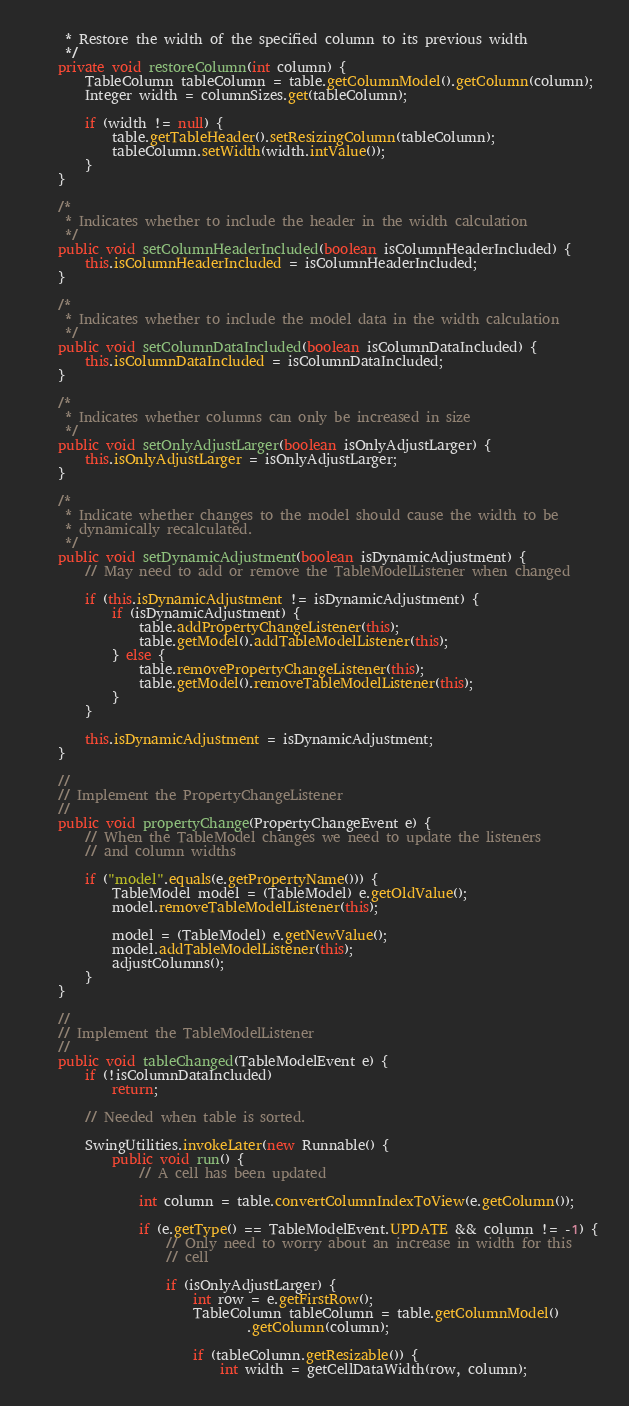Convert code to text. <code><loc_0><loc_0><loc_500><loc_500><_Java_>     * Restore the width of the specified column to its previous width
     */
    private void restoreColumn(int column) {
        TableColumn tableColumn = table.getColumnModel().getColumn(column);
        Integer width = columnSizes.get(tableColumn);

        if (width != null) {
            table.getTableHeader().setResizingColumn(tableColumn);
            tableColumn.setWidth(width.intValue());
        }
    }

    /*
     * Indicates whether to include the header in the width calculation
     */
    public void setColumnHeaderIncluded(boolean isColumnHeaderIncluded) {
        this.isColumnHeaderIncluded = isColumnHeaderIncluded;
    }

    /*
     * Indicates whether to include the model data in the width calculation
     */
    public void setColumnDataIncluded(boolean isColumnDataIncluded) {
        this.isColumnDataIncluded = isColumnDataIncluded;
    }

    /*
     * Indicates whether columns can only be increased in size
     */
    public void setOnlyAdjustLarger(boolean isOnlyAdjustLarger) {
        this.isOnlyAdjustLarger = isOnlyAdjustLarger;
    }

    /*
     * Indicate whether changes to the model should cause the width to be
     * dynamically recalculated.
     */
    public void setDynamicAdjustment(boolean isDynamicAdjustment) {
        // May need to add or remove the TableModelListener when changed

        if (this.isDynamicAdjustment != isDynamicAdjustment) {
            if (isDynamicAdjustment) {
                table.addPropertyChangeListener(this);
                table.getModel().addTableModelListener(this);
            } else {
                table.removePropertyChangeListener(this);
                table.getModel().removeTableModelListener(this);
            }
        }

        this.isDynamicAdjustment = isDynamicAdjustment;
    }

    //
    // Implement the PropertyChangeListener
    //
    public void propertyChange(PropertyChangeEvent e) {
        // When the TableModel changes we need to update the listeners
        // and column widths

        if ("model".equals(e.getPropertyName())) {
            TableModel model = (TableModel) e.getOldValue();
            model.removeTableModelListener(this);

            model = (TableModel) e.getNewValue();
            model.addTableModelListener(this);
            adjustColumns();
        }
    }

    //
    // Implement the TableModelListener
    //
    public void tableChanged(TableModelEvent e) {
        if (!isColumnDataIncluded)
            return;

        // Needed when table is sorted.

        SwingUtilities.invokeLater(new Runnable() {
            public void run() {
                // A cell has been updated

                int column = table.convertColumnIndexToView(e.getColumn());

                if (e.getType() == TableModelEvent.UPDATE && column != -1) {
                    // Only need to worry about an increase in width for this
                    // cell

                    if (isOnlyAdjustLarger) {
                        int row = e.getFirstRow();
                        TableColumn tableColumn = table.getColumnModel()
                                .getColumn(column);

                        if (tableColumn.getResizable()) {
                            int width = getCellDataWidth(row, column);</code> 